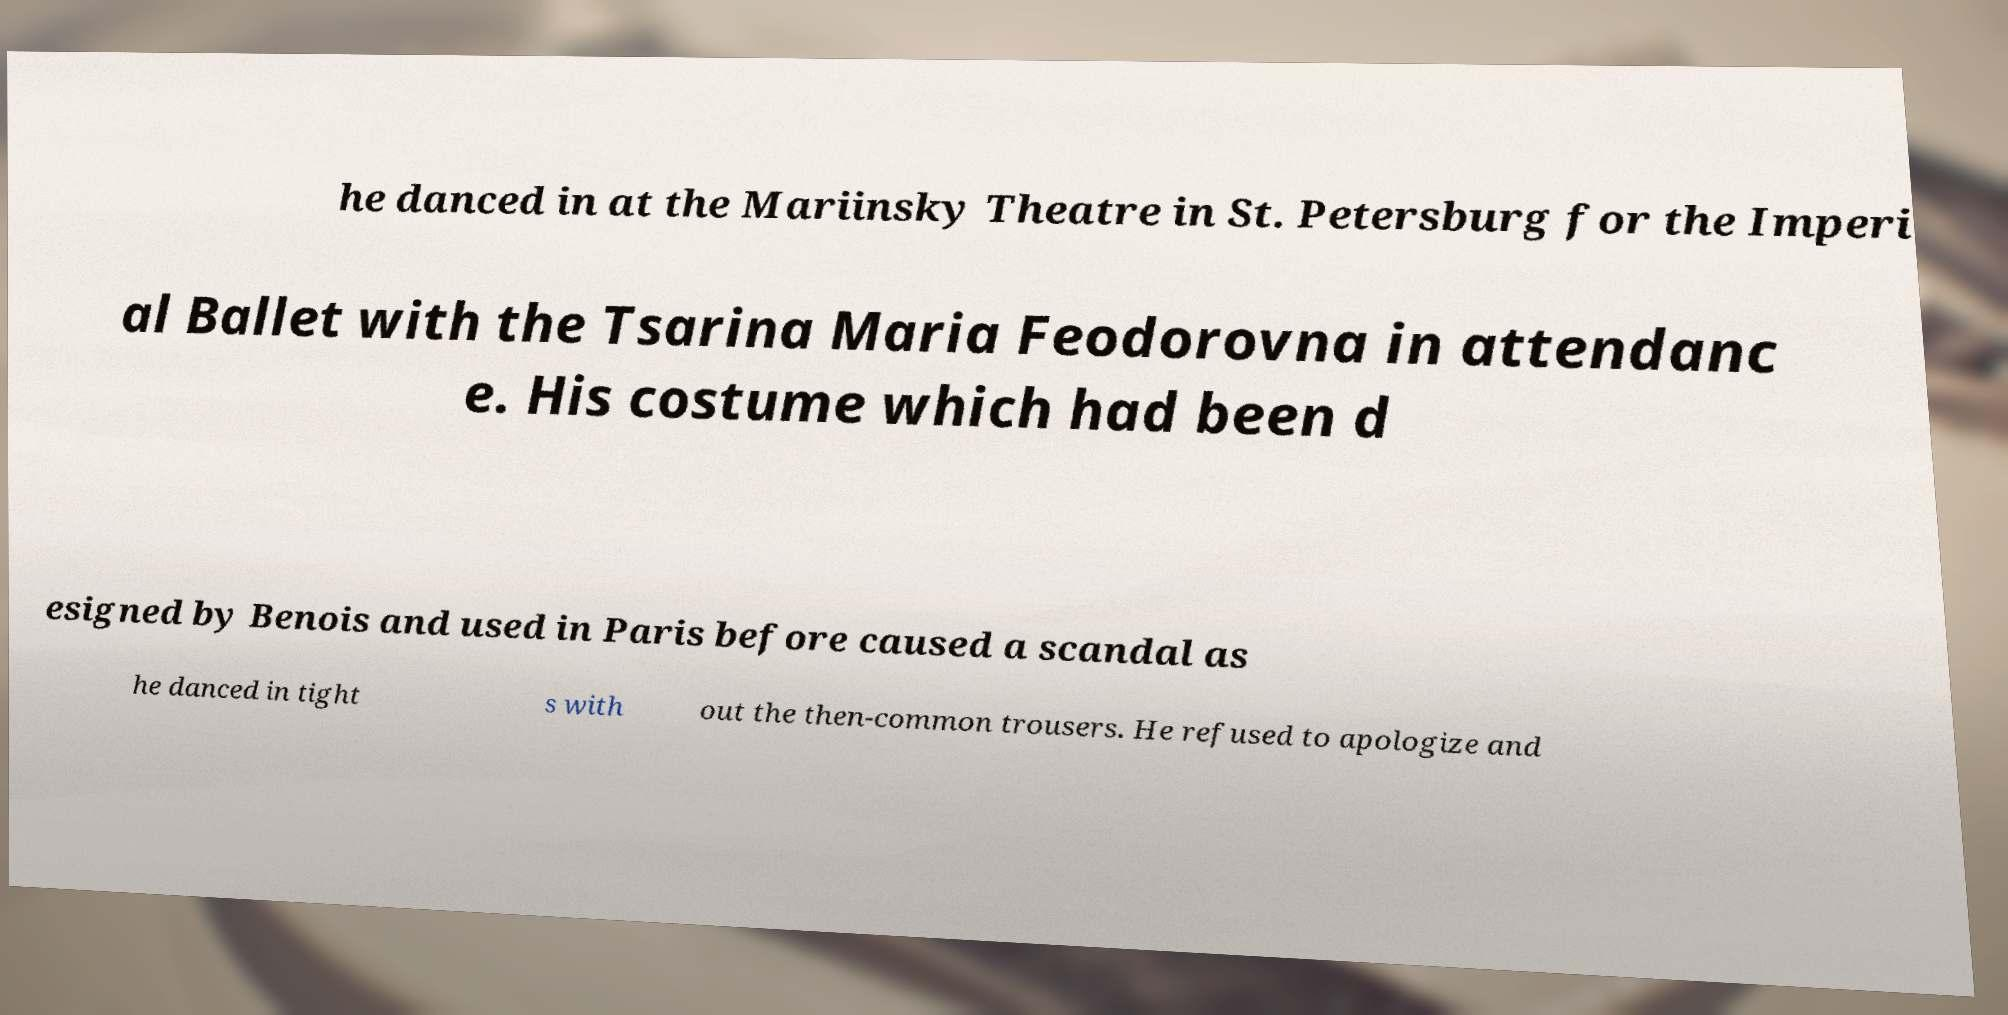What messages or text are displayed in this image? I need them in a readable, typed format. he danced in at the Mariinsky Theatre in St. Petersburg for the Imperi al Ballet with the Tsarina Maria Feodorovna in attendanc e. His costume which had been d esigned by Benois and used in Paris before caused a scandal as he danced in tight s with out the then-common trousers. He refused to apologize and 